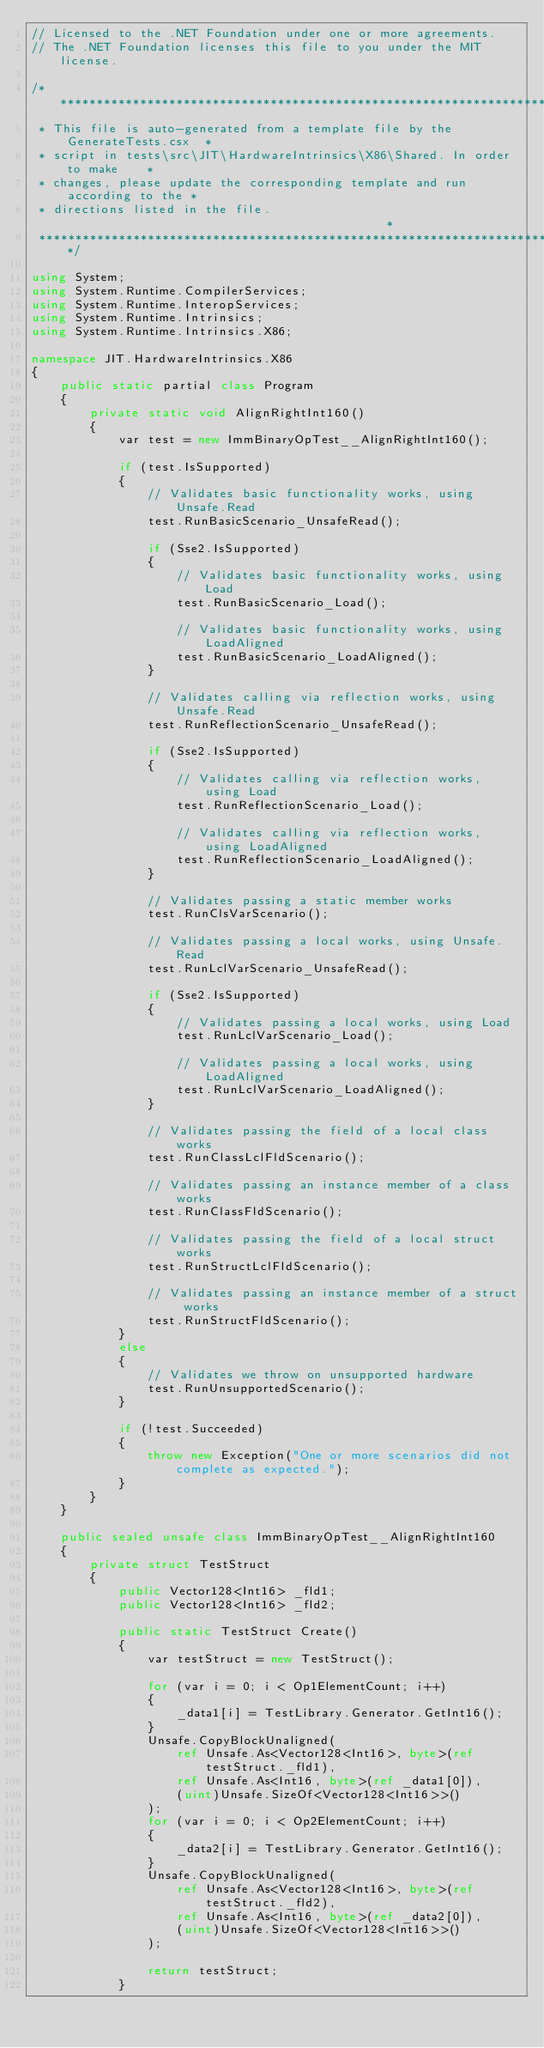<code> <loc_0><loc_0><loc_500><loc_500><_C#_>// Licensed to the .NET Foundation under one or more agreements.
// The .NET Foundation licenses this file to you under the MIT license.

/******************************************************************************
 * This file is auto-generated from a template file by the GenerateTests.csx  *
 * script in tests\src\JIT\HardwareIntrinsics\X86\Shared. In order to make    *
 * changes, please update the corresponding template and run according to the *
 * directions listed in the file.                                             *
 ******************************************************************************/

using System;
using System.Runtime.CompilerServices;
using System.Runtime.InteropServices;
using System.Runtime.Intrinsics;
using System.Runtime.Intrinsics.X86;

namespace JIT.HardwareIntrinsics.X86
{
    public static partial class Program
    {
        private static void AlignRightInt160()
        {
            var test = new ImmBinaryOpTest__AlignRightInt160();

            if (test.IsSupported)
            {
                // Validates basic functionality works, using Unsafe.Read
                test.RunBasicScenario_UnsafeRead();

                if (Sse2.IsSupported)
                {
                    // Validates basic functionality works, using Load
                    test.RunBasicScenario_Load();

                    // Validates basic functionality works, using LoadAligned
                    test.RunBasicScenario_LoadAligned();
                }

                // Validates calling via reflection works, using Unsafe.Read
                test.RunReflectionScenario_UnsafeRead();

                if (Sse2.IsSupported)
                {
                    // Validates calling via reflection works, using Load
                    test.RunReflectionScenario_Load();

                    // Validates calling via reflection works, using LoadAligned
                    test.RunReflectionScenario_LoadAligned();
                }

                // Validates passing a static member works
                test.RunClsVarScenario();

                // Validates passing a local works, using Unsafe.Read
                test.RunLclVarScenario_UnsafeRead();

                if (Sse2.IsSupported)
                {
                    // Validates passing a local works, using Load
                    test.RunLclVarScenario_Load();

                    // Validates passing a local works, using LoadAligned
                    test.RunLclVarScenario_LoadAligned();
                }

                // Validates passing the field of a local class works
                test.RunClassLclFldScenario();

                // Validates passing an instance member of a class works
                test.RunClassFldScenario();

                // Validates passing the field of a local struct works
                test.RunStructLclFldScenario();

                // Validates passing an instance member of a struct works
                test.RunStructFldScenario();
            }
            else
            {
                // Validates we throw on unsupported hardware
                test.RunUnsupportedScenario();
            }

            if (!test.Succeeded)
            {
                throw new Exception("One or more scenarios did not complete as expected.");
            }
        }
    }

    public sealed unsafe class ImmBinaryOpTest__AlignRightInt160
    {
        private struct TestStruct
        {
            public Vector128<Int16> _fld1;
            public Vector128<Int16> _fld2;

            public static TestStruct Create()
            {
                var testStruct = new TestStruct();

                for (var i = 0; i < Op1ElementCount; i++)
                {
                    _data1[i] = TestLibrary.Generator.GetInt16();
                }
                Unsafe.CopyBlockUnaligned(
                    ref Unsafe.As<Vector128<Int16>, byte>(ref testStruct._fld1),
                    ref Unsafe.As<Int16, byte>(ref _data1[0]),
                    (uint)Unsafe.SizeOf<Vector128<Int16>>()
                );
                for (var i = 0; i < Op2ElementCount; i++)
                {
                    _data2[i] = TestLibrary.Generator.GetInt16();
                }
                Unsafe.CopyBlockUnaligned(
                    ref Unsafe.As<Vector128<Int16>, byte>(ref testStruct._fld2),
                    ref Unsafe.As<Int16, byte>(ref _data2[0]),
                    (uint)Unsafe.SizeOf<Vector128<Int16>>()
                );

                return testStruct;
            }
</code> 